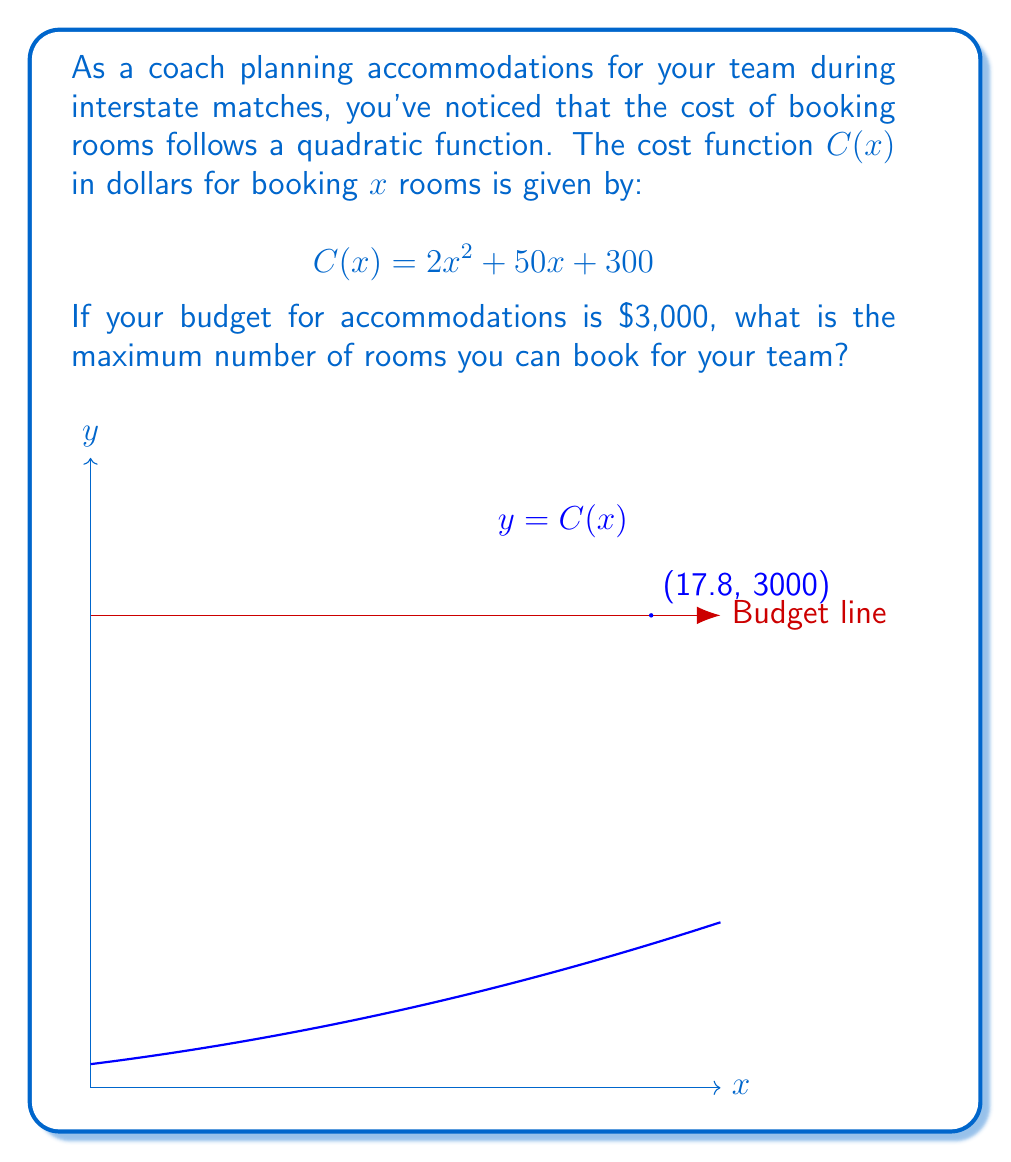Can you solve this math problem? Let's approach this step-by-step:

1) We need to find the largest value of $x$ where $C(x) \leq 3000$.

2) This means solving the inequality:
   $$2x^2 + 50x + 300 \leq 3000$$

3) Rearrange the inequality:
   $$2x^2 + 50x - 2700 \leq 0$$

4) This is a quadratic inequality. To solve it, we first find the roots of the corresponding equation:
   $$2x^2 + 50x - 2700 = 0$$

5) Using the quadratic formula, $x = \frac{-b \pm \sqrt{b^2 - 4ac}}{2a}$, where $a=2$, $b=50$, and $c=-2700$:
   $$x = \frac{-50 \pm \sqrt{50^2 - 4(2)(-2700)}}{2(2)}$$
   $$= \frac{-50 \pm \sqrt{2500 + 21600}}{4}$$
   $$= \frac{-50 \pm \sqrt{24100}}{4}$$
   $$= \frac{-50 \pm 155.24}{4}$$

6) This gives us two roots:
   $x_1 = \frac{-50 + 155.24}{4} = 26.31$
   $x_2 = \frac{-50 - 155.24}{4} = -51.31$

7) The inequality is satisfied when $x$ is between these two roots. Since we can't have a negative number of rooms, our maximum $x$ is 26.31.

8) However, we need to round down to the nearest whole number, as we can't book partial rooms.

Therefore, the maximum number of rooms you can book is 26.
Answer: 26 rooms 